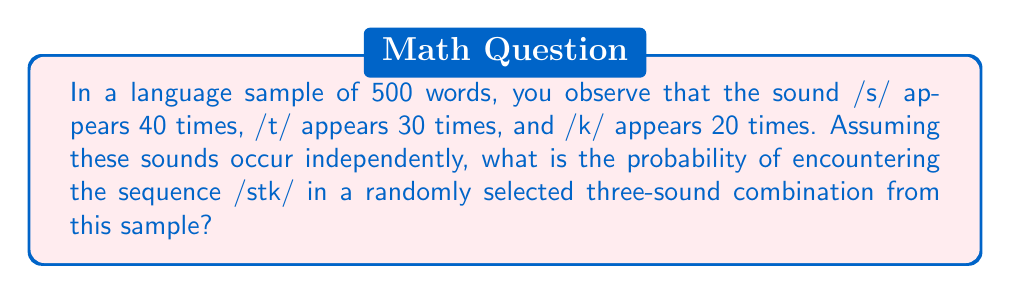What is the answer to this math problem? To solve this problem, we need to follow these steps:

1) First, calculate the probability of each sound occurring:
   P(s) = 40/500 = 1/12.5 = 0.08
   P(t) = 30/500 = 1/16.67 ≈ 0.06
   P(k) = 20/500 = 1/25 = 0.04

2) Since we assume the sounds occur independently, we can use the multiplication rule of probability. The probability of the sequence /stk/ occurring is:

   P(stk) = P(s) × P(t) × P(k)

3) Substitute the probabilities:

   P(stk) = 0.08 × 0.06 × 0.04

4) Calculate:

   P(stk) = 0.000192

5) Convert to a fraction:

   P(stk) = 192/1,000,000 = 24/125,000

Therefore, the probability of encountering the sequence /stk/ in a randomly selected three-sound combination from this sample is 24/125,000.
Answer: $\frac{24}{125,000}$ 